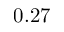Convert formula to latex. <formula><loc_0><loc_0><loc_500><loc_500>0 . 2 7</formula> 